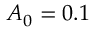Convert formula to latex. <formula><loc_0><loc_0><loc_500><loc_500>A _ { 0 } = 0 . 1</formula> 